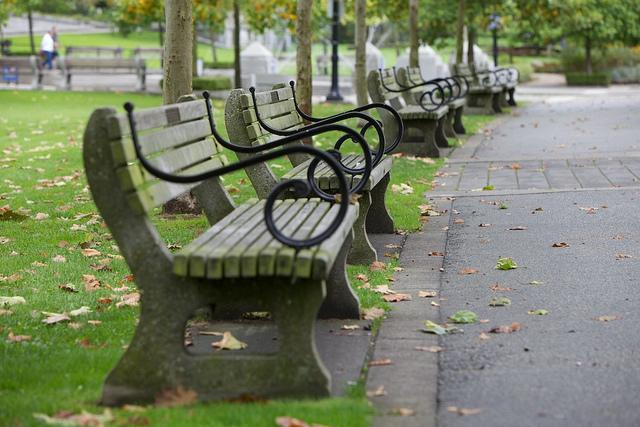What is on the grass? leaves 